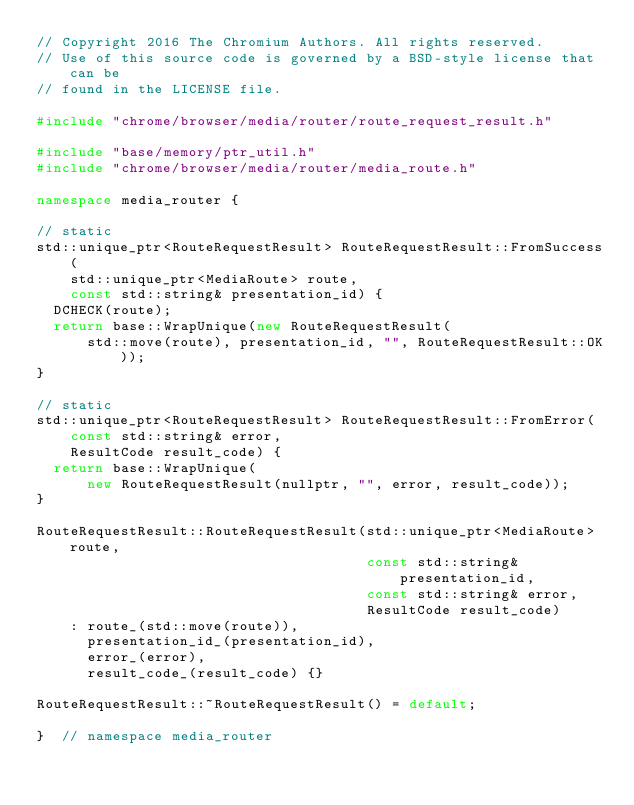<code> <loc_0><loc_0><loc_500><loc_500><_C++_>// Copyright 2016 The Chromium Authors. All rights reserved.
// Use of this source code is governed by a BSD-style license that can be
// found in the LICENSE file.

#include "chrome/browser/media/router/route_request_result.h"

#include "base/memory/ptr_util.h"
#include "chrome/browser/media/router/media_route.h"

namespace media_router {

// static
std::unique_ptr<RouteRequestResult> RouteRequestResult::FromSuccess(
    std::unique_ptr<MediaRoute> route,
    const std::string& presentation_id) {
  DCHECK(route);
  return base::WrapUnique(new RouteRequestResult(
      std::move(route), presentation_id, "", RouteRequestResult::OK));
}

// static
std::unique_ptr<RouteRequestResult> RouteRequestResult::FromError(
    const std::string& error,
    ResultCode result_code) {
  return base::WrapUnique(
      new RouteRequestResult(nullptr, "", error, result_code));
}

RouteRequestResult::RouteRequestResult(std::unique_ptr<MediaRoute> route,
                                       const std::string& presentation_id,
                                       const std::string& error,
                                       ResultCode result_code)
    : route_(std::move(route)),
      presentation_id_(presentation_id),
      error_(error),
      result_code_(result_code) {}

RouteRequestResult::~RouteRequestResult() = default;

}  // namespace media_router
</code> 